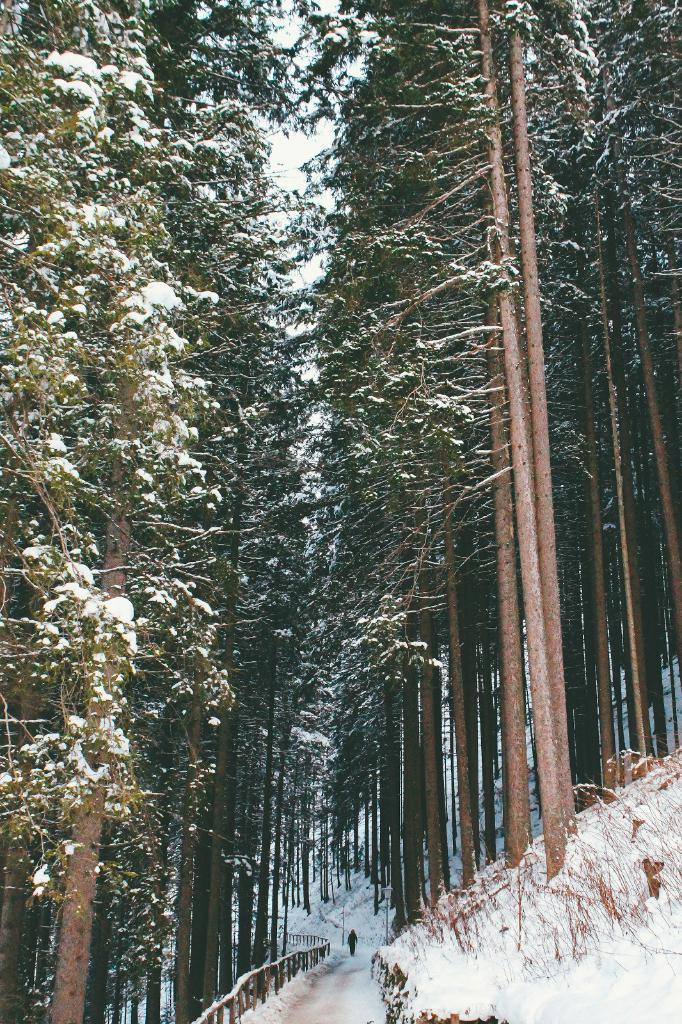What is the man doing in the image? The man is walking on a bridge in the image. What is the condition of the bridge in the image? The bridge is covered with ice. What can be seen in the background of the image? There are many trees in the image. What is the condition of the trees in the image? The trees are covered with ice. What type of sack is the man carrying on his vacation in the image? There is no mention of a sack or vacation in the image; the man is simply walking on a bridge with icy conditions. 